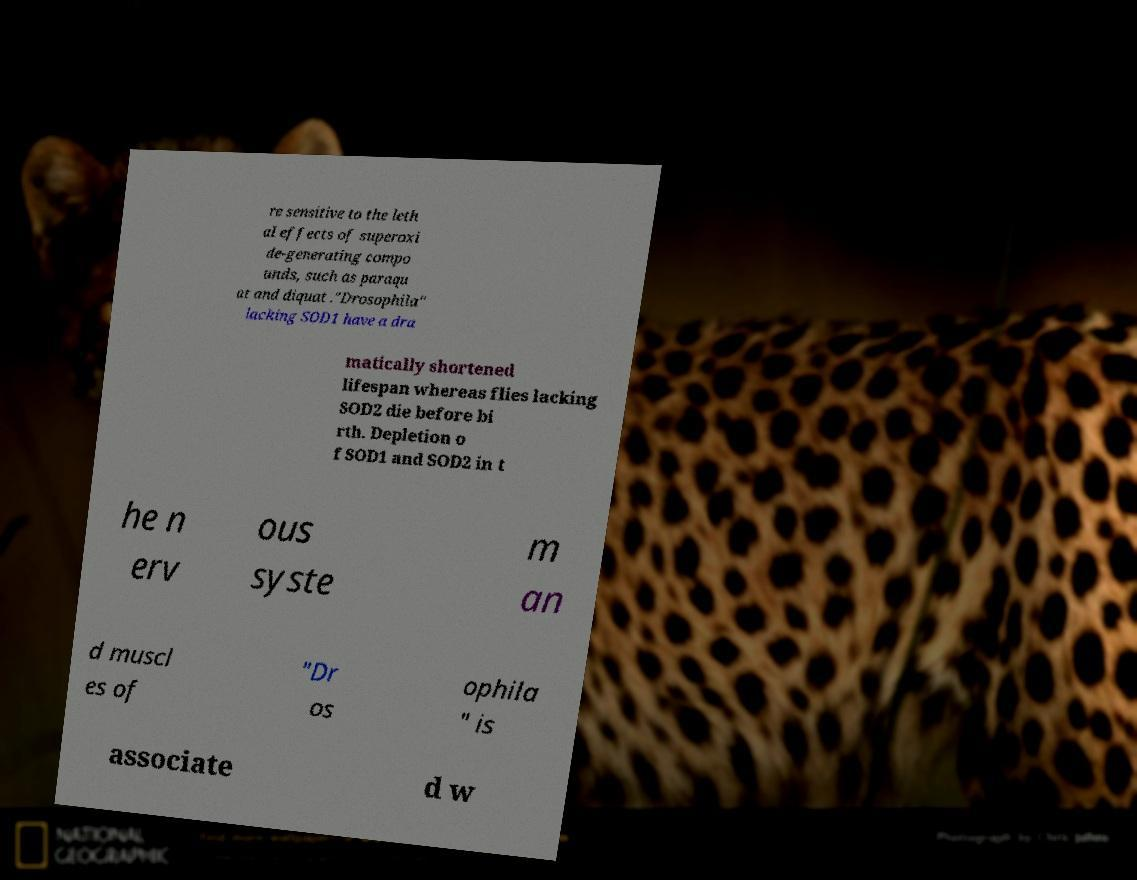Can you accurately transcribe the text from the provided image for me? re sensitive to the leth al effects of superoxi de-generating compo unds, such as paraqu at and diquat ."Drosophila" lacking SOD1 have a dra matically shortened lifespan whereas flies lacking SOD2 die before bi rth. Depletion o f SOD1 and SOD2 in t he n erv ous syste m an d muscl es of "Dr os ophila " is associate d w 